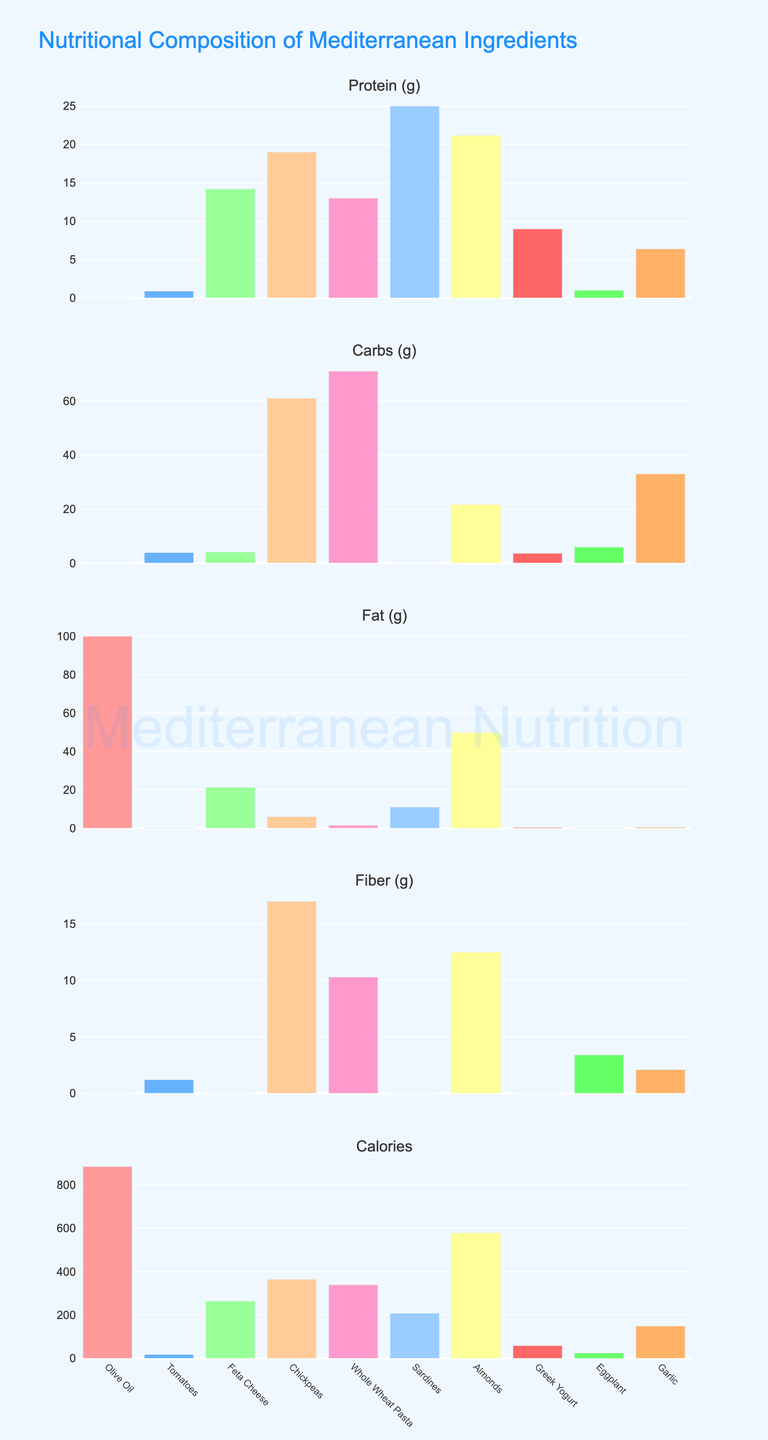What is the title of the figure? The title of the figure is located at the top center and is used to convey the main subject of the plot. In this figure, the title reads "Nutritional Composition of Mediterranean Ingredients."
Answer: Nutritional Composition of Mediterranean Ingredients How many ingredients are compared in the plot? Each subplot has bars representing the number of different ingredients being compared. By counting the distinct bars in one subplot, we can see that there are 10 ingredients being compared.
Answer: 10 Which ingredient has the highest fat content? To find the ingredient with the highest fat content, we look at the 'Fat (g)' subplot. The tallest bar in this subplot indicates the ingredient with the highest fat content, which is Olive Oil.
Answer: Olive Oil What are the protein contents of Feta Cheese and Sardines, and which one is higher? In the 'Protein (g)' subplot, Feta Cheese and Sardines have bars indicating their protein contents as 14.2g and 25g respectively. Comparing these two values, Sardines has a higher protein content.
Answer: Feta Cheese: 14.2g, Sardines: 25g. Sardines has higher protein Which ingredient has the highest number of calories and how much are they? In the 'Calories' subplot, the tallest bar indicates the ingredient with the highest number of calories. That bar corresponds to Olive Oil, which has 884 calories.
Answer: Olive Oil, 884 calories Do tomatoes contain any fat? In the 'Fat (g)' subplot, the bar representing Tomatoes is very short, indicating a very low amount of fat content. Specifically, Tomatoes have 0.2g of fat.
Answer: Yes, 0.2g What is the difference in carbohydrate content between Chickpeas and Whole Wheat Pasta? The carbohydrate content of Chickpeas is 61g and that of Whole Wheat Pasta is 71g, as seen in the 'Carbs (g)' subplot. The difference in carbohydrate content is calculated as 71g - 61g = 10g.
Answer: 10g Which ingredients have more than 10g of fiber? In the 'Fiber (g)' subplot, the bars for Chickpeas and Almonds exceed 10g. Chickpeas have 17g and Almonds have 12.5g of fiber.
Answer: Chickpeas, Almonds What is the average fat content of Feta Cheese, Sardines, and Almonds? The fat content of Feta Cheese is 21.3g, Sardines is 11g, and Almonds is 49.9g. The average fat content is calculated as (21.3 + 11 + 49.9) / 3 ≈ 27.4g.
Answer: 27.4g Is the fiber content of Eggplant higher than that of Garlic? In the 'Fiber (g)' subplot, Eggplant has a fiber content of 3.4g while Garlic has a fiber content of 2.1g. Therefore, Eggplant's fiber content is higher.
Answer: Yes 